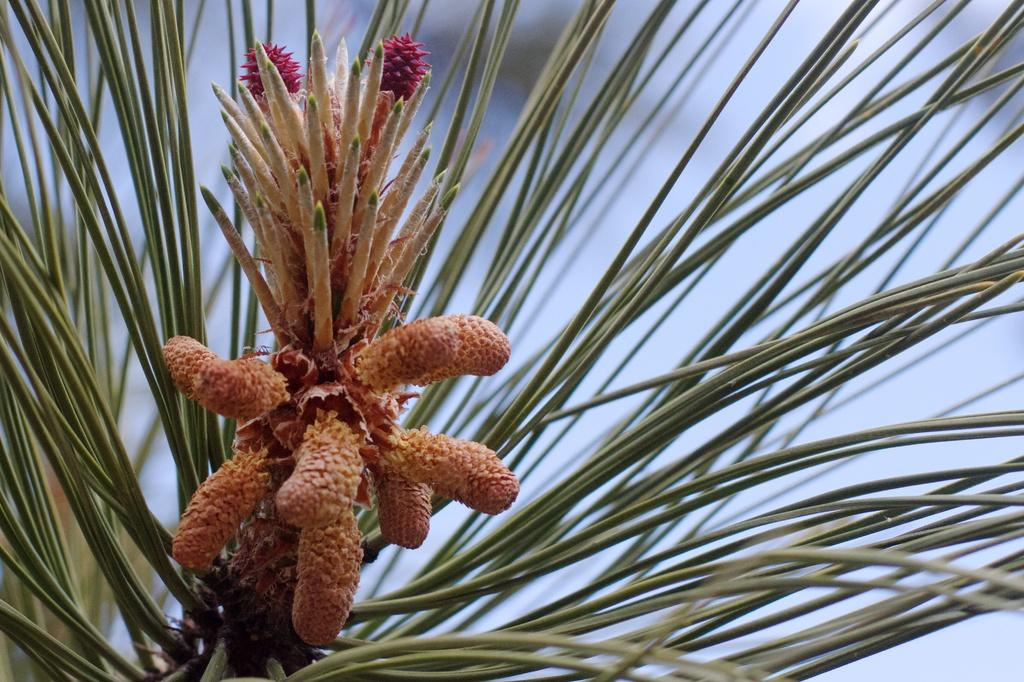What is the main subject of the picture? The main subject of the picture is a plant. Can you describe the plant in more detail? The plant has flowers and buds in the foreground. What can be observed about the background of the image? The background of the image is blurred. What type of pets can be seen playing with the plant in the image? There are no pets present in the image, and therefore no such activity can be observed. 